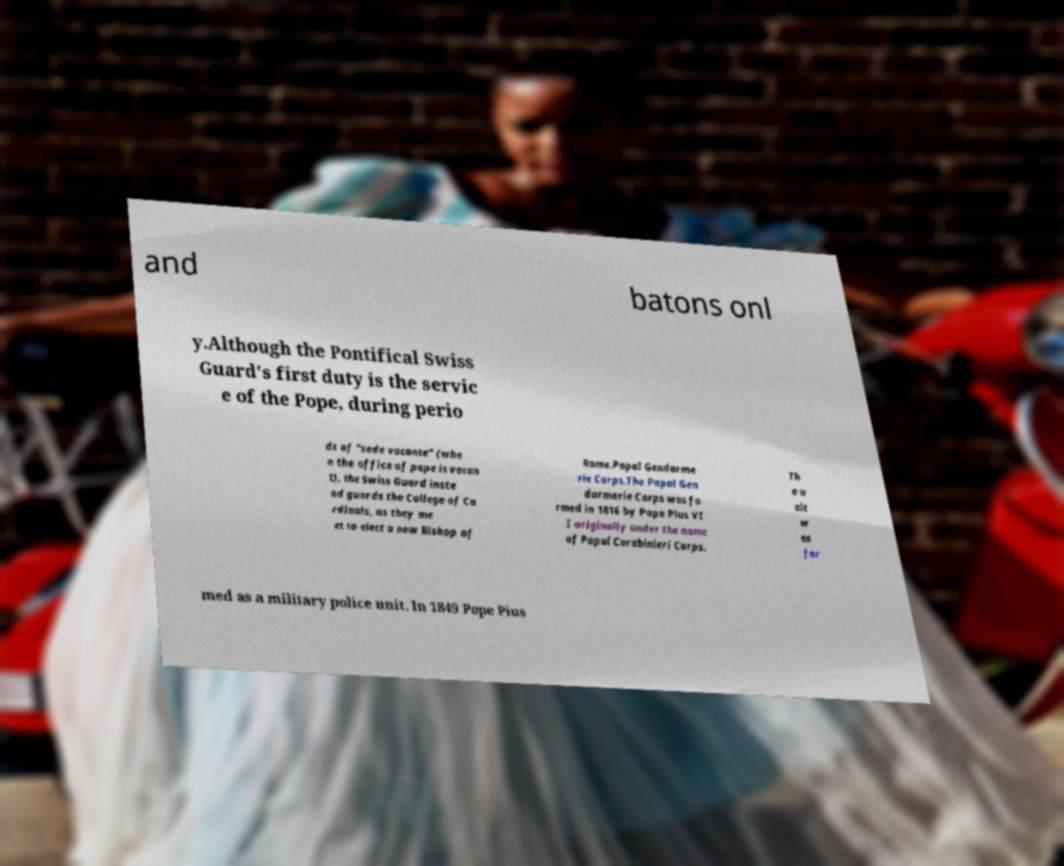Can you read and provide the text displayed in the image?This photo seems to have some interesting text. Can you extract and type it out for me? and batons onl y.Although the Pontifical Swiss Guard's first duty is the servic e of the Pope, during perio ds of "sede vacante" (whe n the office of pope is vacan t), the Swiss Guard inste ad guards the College of Ca rdinals, as they me et to elect a new Bishop of Rome.Papal Gendarme rie Corps.The Papal Gen darmerie Corps was fo rmed in 1816 by Pope Pius VI I originally under the name of Papal Carabinieri Corps. Th e u nit w as for med as a military police unit. In 1849 Pope Pius 